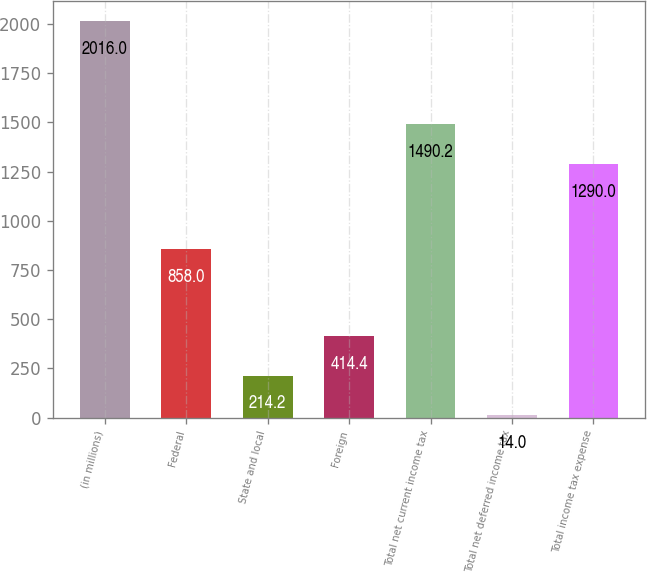Convert chart to OTSL. <chart><loc_0><loc_0><loc_500><loc_500><bar_chart><fcel>(in millions)<fcel>Federal<fcel>State and local<fcel>Foreign<fcel>Total net current income tax<fcel>Total net deferred income tax<fcel>Total income tax expense<nl><fcel>2016<fcel>858<fcel>214.2<fcel>414.4<fcel>1490.2<fcel>14<fcel>1290<nl></chart> 